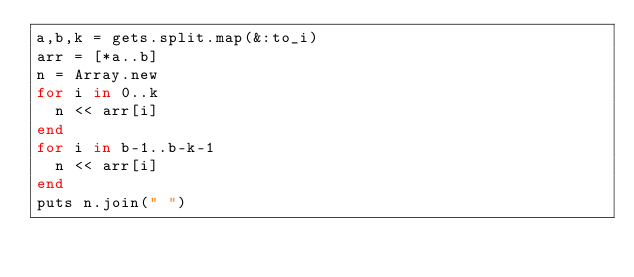<code> <loc_0><loc_0><loc_500><loc_500><_Ruby_>a,b,k = gets.split.map(&:to_i)
arr = [*a..b]
n = Array.new
for i in 0..k
  n << arr[i]
end
for i in b-1..b-k-1
  n << arr[i]
end
puts n.join(" ")</code> 